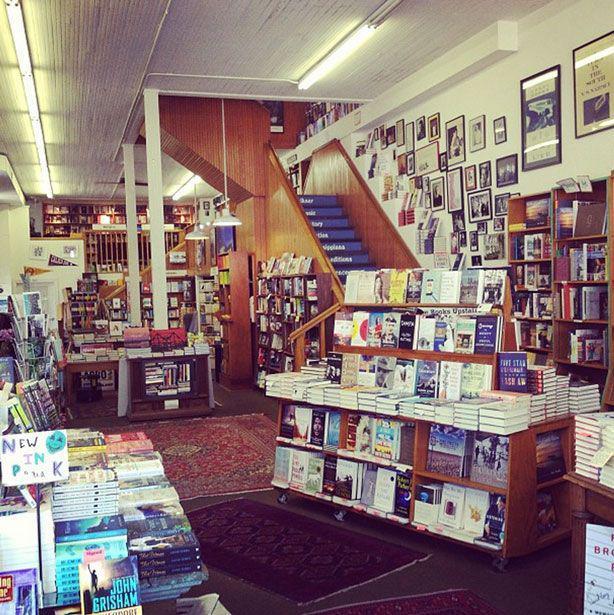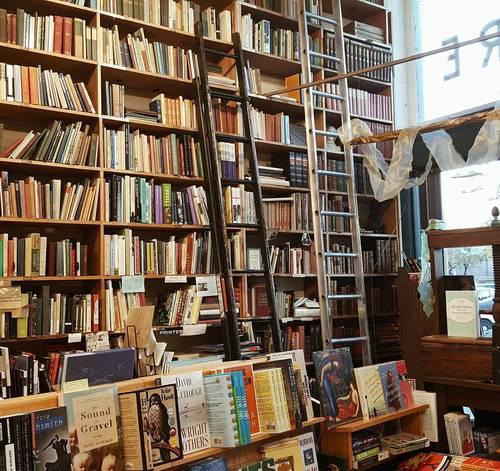The first image is the image on the left, the second image is the image on the right. Examine the images to the left and right. Is the description "There is 1 or more person(s) browsing the book selections." accurate? Answer yes or no. No. The first image is the image on the left, the second image is the image on the right. For the images shown, is this caption "There is a person in at least one of the photos." true? Answer yes or no. No. 